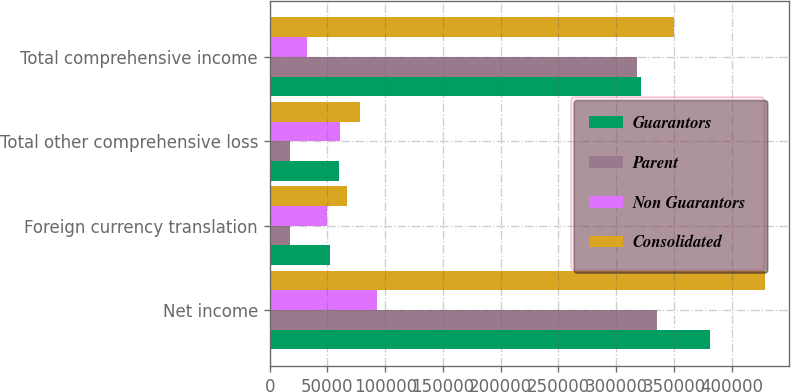Convert chart to OTSL. <chart><loc_0><loc_0><loc_500><loc_500><stacked_bar_chart><ecel><fcel>Net income<fcel>Foreign currency translation<fcel>Total other comprehensive loss<fcel>Total comprehensive income<nl><fcel>Guarantors<fcel>381519<fcel>51979<fcel>60236<fcel>321283<nl><fcel>Parent<fcel>335489<fcel>17710<fcel>17710<fcel>317779<nl><fcel>Non Guarantors<fcel>92962<fcel>49559<fcel>60455<fcel>32507<nl><fcel>Consolidated<fcel>428451<fcel>67269<fcel>78165<fcel>350286<nl></chart> 